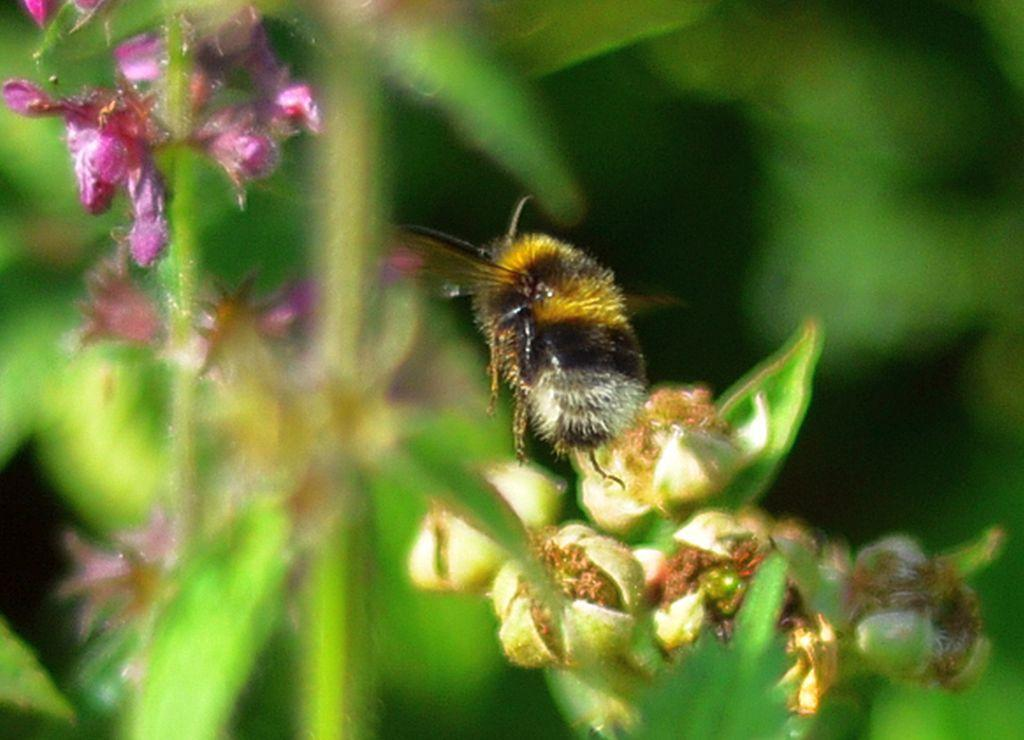What type of insect is present in the image? There is a bee in the image. Where is the bee located in the image? The bee is on the flowers of a plant. What type of paper is the bee using to build its nest in the image? There is no paper present in the image, and bees do not use paper to build their nests. 